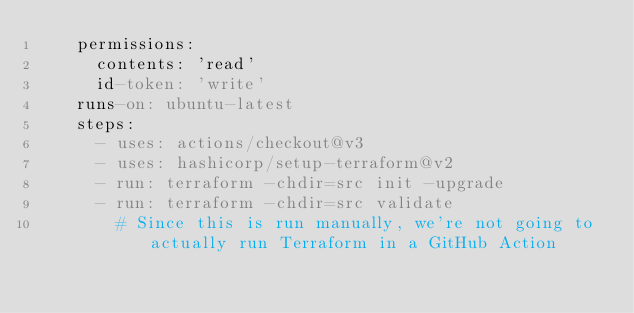<code> <loc_0><loc_0><loc_500><loc_500><_YAML_>    permissions:
      contents: 'read'
      id-token: 'write'
    runs-on: ubuntu-latest
    steps:
      - uses: actions/checkout@v3
      - uses: hashicorp/setup-terraform@v2
      - run: terraform -chdir=src init -upgrade
      - run: terraform -chdir=src validate
        # Since this is run manually, we're not going to actually run Terraform in a GitHub Action</code> 